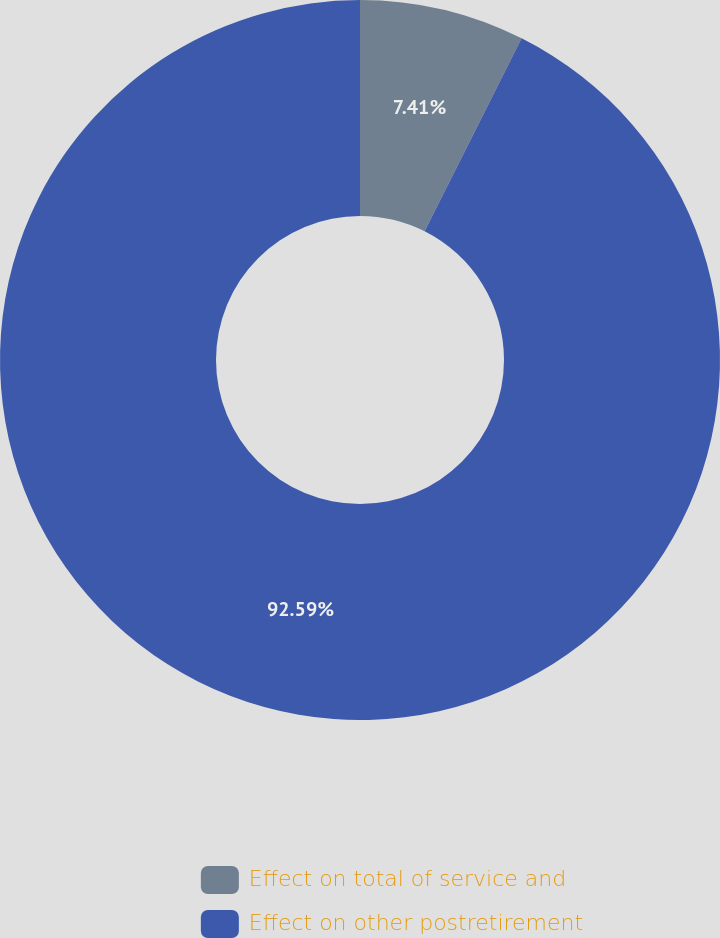Convert chart to OTSL. <chart><loc_0><loc_0><loc_500><loc_500><pie_chart><fcel>Effect on total of service and<fcel>Effect on other postretirement<nl><fcel>7.41%<fcel>92.59%<nl></chart> 